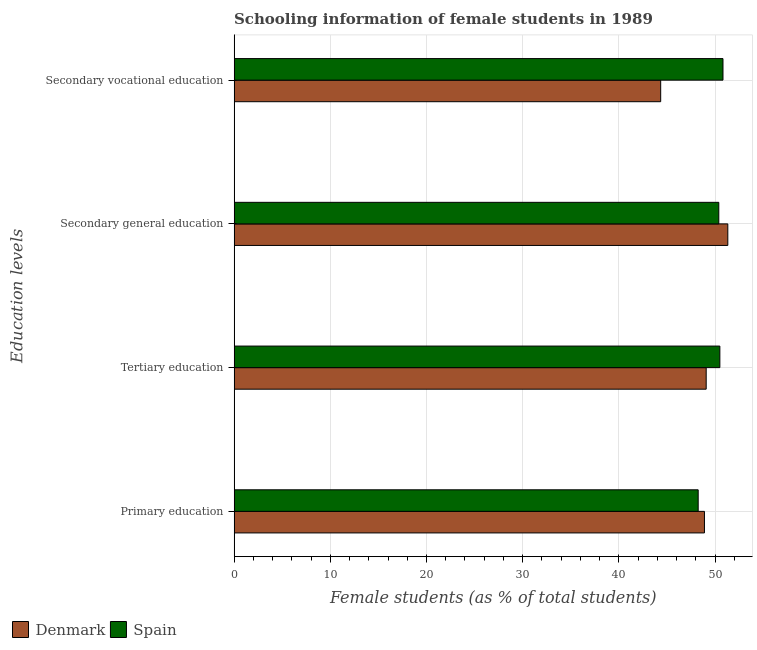How many groups of bars are there?
Your answer should be very brief. 4. Are the number of bars on each tick of the Y-axis equal?
Provide a succinct answer. Yes. What is the label of the 2nd group of bars from the top?
Keep it short and to the point. Secondary general education. What is the percentage of female students in secondary vocational education in Denmark?
Make the answer very short. 44.34. Across all countries, what is the maximum percentage of female students in secondary education?
Give a very brief answer. 51.32. Across all countries, what is the minimum percentage of female students in secondary education?
Your answer should be very brief. 50.39. In which country was the percentage of female students in secondary education maximum?
Provide a short and direct response. Denmark. In which country was the percentage of female students in secondary education minimum?
Give a very brief answer. Spain. What is the total percentage of female students in primary education in the graph?
Make the answer very short. 97.14. What is the difference between the percentage of female students in secondary education in Spain and that in Denmark?
Offer a terse response. -0.94. What is the difference between the percentage of female students in secondary education in Denmark and the percentage of female students in primary education in Spain?
Keep it short and to the point. 3.08. What is the average percentage of female students in secondary education per country?
Your response must be concise. 50.85. What is the difference between the percentage of female students in primary education and percentage of female students in secondary education in Spain?
Offer a very short reply. -2.14. In how many countries, is the percentage of female students in primary education greater than 2 %?
Your response must be concise. 2. What is the ratio of the percentage of female students in primary education in Spain to that in Denmark?
Offer a very short reply. 0.99. Is the difference between the percentage of female students in primary education in Denmark and Spain greater than the difference between the percentage of female students in secondary education in Denmark and Spain?
Keep it short and to the point. No. What is the difference between the highest and the second highest percentage of female students in tertiary education?
Offer a very short reply. 1.42. What is the difference between the highest and the lowest percentage of female students in secondary vocational education?
Offer a very short reply. 6.48. In how many countries, is the percentage of female students in primary education greater than the average percentage of female students in primary education taken over all countries?
Your response must be concise. 1. Is it the case that in every country, the sum of the percentage of female students in tertiary education and percentage of female students in secondary education is greater than the sum of percentage of female students in secondary vocational education and percentage of female students in primary education?
Provide a succinct answer. No. What does the 1st bar from the bottom in Tertiary education represents?
Make the answer very short. Denmark. Is it the case that in every country, the sum of the percentage of female students in primary education and percentage of female students in tertiary education is greater than the percentage of female students in secondary education?
Your answer should be very brief. Yes. Are all the bars in the graph horizontal?
Offer a very short reply. Yes. Does the graph contain any zero values?
Ensure brevity in your answer.  No. What is the title of the graph?
Your answer should be compact. Schooling information of female students in 1989. Does "Mexico" appear as one of the legend labels in the graph?
Your response must be concise. No. What is the label or title of the X-axis?
Keep it short and to the point. Female students (as % of total students). What is the label or title of the Y-axis?
Your answer should be compact. Education levels. What is the Female students (as % of total students) in Denmark in Primary education?
Provide a short and direct response. 48.89. What is the Female students (as % of total students) of Spain in Primary education?
Your answer should be very brief. 48.24. What is the Female students (as % of total students) of Denmark in Tertiary education?
Offer a very short reply. 49.07. What is the Female students (as % of total students) in Spain in Tertiary education?
Offer a very short reply. 50.5. What is the Female students (as % of total students) of Denmark in Secondary general education?
Offer a very short reply. 51.32. What is the Female students (as % of total students) in Spain in Secondary general education?
Give a very brief answer. 50.39. What is the Female students (as % of total students) in Denmark in Secondary vocational education?
Your response must be concise. 44.34. What is the Female students (as % of total students) of Spain in Secondary vocational education?
Your answer should be compact. 50.82. Across all Education levels, what is the maximum Female students (as % of total students) in Denmark?
Offer a terse response. 51.32. Across all Education levels, what is the maximum Female students (as % of total students) in Spain?
Your response must be concise. 50.82. Across all Education levels, what is the minimum Female students (as % of total students) in Denmark?
Ensure brevity in your answer.  44.34. Across all Education levels, what is the minimum Female students (as % of total students) in Spain?
Provide a short and direct response. 48.24. What is the total Female students (as % of total students) in Denmark in the graph?
Provide a short and direct response. 193.63. What is the total Female students (as % of total students) in Spain in the graph?
Keep it short and to the point. 199.95. What is the difference between the Female students (as % of total students) of Denmark in Primary education and that in Tertiary education?
Provide a succinct answer. -0.18. What is the difference between the Female students (as % of total students) in Spain in Primary education and that in Tertiary education?
Your answer should be compact. -2.25. What is the difference between the Female students (as % of total students) of Denmark in Primary education and that in Secondary general education?
Ensure brevity in your answer.  -2.43. What is the difference between the Female students (as % of total students) in Spain in Primary education and that in Secondary general education?
Ensure brevity in your answer.  -2.14. What is the difference between the Female students (as % of total students) in Denmark in Primary education and that in Secondary vocational education?
Offer a terse response. 4.55. What is the difference between the Female students (as % of total students) of Spain in Primary education and that in Secondary vocational education?
Keep it short and to the point. -2.58. What is the difference between the Female students (as % of total students) of Denmark in Tertiary education and that in Secondary general education?
Make the answer very short. -2.25. What is the difference between the Female students (as % of total students) in Denmark in Tertiary education and that in Secondary vocational education?
Your response must be concise. 4.73. What is the difference between the Female students (as % of total students) in Spain in Tertiary education and that in Secondary vocational education?
Ensure brevity in your answer.  -0.33. What is the difference between the Female students (as % of total students) of Denmark in Secondary general education and that in Secondary vocational education?
Provide a succinct answer. 6.98. What is the difference between the Female students (as % of total students) of Spain in Secondary general education and that in Secondary vocational education?
Keep it short and to the point. -0.44. What is the difference between the Female students (as % of total students) in Denmark in Primary education and the Female students (as % of total students) in Spain in Tertiary education?
Keep it short and to the point. -1.6. What is the difference between the Female students (as % of total students) in Denmark in Primary education and the Female students (as % of total students) in Spain in Secondary general education?
Give a very brief answer. -1.49. What is the difference between the Female students (as % of total students) of Denmark in Primary education and the Female students (as % of total students) of Spain in Secondary vocational education?
Offer a terse response. -1.93. What is the difference between the Female students (as % of total students) of Denmark in Tertiary education and the Female students (as % of total students) of Spain in Secondary general education?
Your response must be concise. -1.31. What is the difference between the Female students (as % of total students) of Denmark in Tertiary education and the Female students (as % of total students) of Spain in Secondary vocational education?
Give a very brief answer. -1.75. What is the difference between the Female students (as % of total students) in Denmark in Secondary general education and the Female students (as % of total students) in Spain in Secondary vocational education?
Offer a terse response. 0.5. What is the average Female students (as % of total students) of Denmark per Education levels?
Offer a terse response. 48.41. What is the average Female students (as % of total students) in Spain per Education levels?
Give a very brief answer. 49.99. What is the difference between the Female students (as % of total students) in Denmark and Female students (as % of total students) in Spain in Primary education?
Your response must be concise. 0.65. What is the difference between the Female students (as % of total students) of Denmark and Female students (as % of total students) of Spain in Tertiary education?
Your response must be concise. -1.42. What is the difference between the Female students (as % of total students) of Denmark and Female students (as % of total students) of Spain in Secondary general education?
Offer a terse response. 0.94. What is the difference between the Female students (as % of total students) in Denmark and Female students (as % of total students) in Spain in Secondary vocational education?
Your answer should be compact. -6.48. What is the ratio of the Female students (as % of total students) in Denmark in Primary education to that in Tertiary education?
Offer a very short reply. 1. What is the ratio of the Female students (as % of total students) in Spain in Primary education to that in Tertiary education?
Give a very brief answer. 0.96. What is the ratio of the Female students (as % of total students) in Denmark in Primary education to that in Secondary general education?
Make the answer very short. 0.95. What is the ratio of the Female students (as % of total students) of Spain in Primary education to that in Secondary general education?
Provide a succinct answer. 0.96. What is the ratio of the Female students (as % of total students) in Denmark in Primary education to that in Secondary vocational education?
Provide a succinct answer. 1.1. What is the ratio of the Female students (as % of total students) in Spain in Primary education to that in Secondary vocational education?
Make the answer very short. 0.95. What is the ratio of the Female students (as % of total students) of Denmark in Tertiary education to that in Secondary general education?
Your response must be concise. 0.96. What is the ratio of the Female students (as % of total students) of Spain in Tertiary education to that in Secondary general education?
Give a very brief answer. 1. What is the ratio of the Female students (as % of total students) in Denmark in Tertiary education to that in Secondary vocational education?
Give a very brief answer. 1.11. What is the ratio of the Female students (as % of total students) of Denmark in Secondary general education to that in Secondary vocational education?
Your answer should be very brief. 1.16. What is the ratio of the Female students (as % of total students) in Spain in Secondary general education to that in Secondary vocational education?
Give a very brief answer. 0.99. What is the difference between the highest and the second highest Female students (as % of total students) in Denmark?
Provide a succinct answer. 2.25. What is the difference between the highest and the second highest Female students (as % of total students) in Spain?
Offer a terse response. 0.33. What is the difference between the highest and the lowest Female students (as % of total students) in Denmark?
Your answer should be compact. 6.98. What is the difference between the highest and the lowest Female students (as % of total students) in Spain?
Provide a short and direct response. 2.58. 